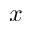<formula> <loc_0><loc_0><loc_500><loc_500>x</formula> 